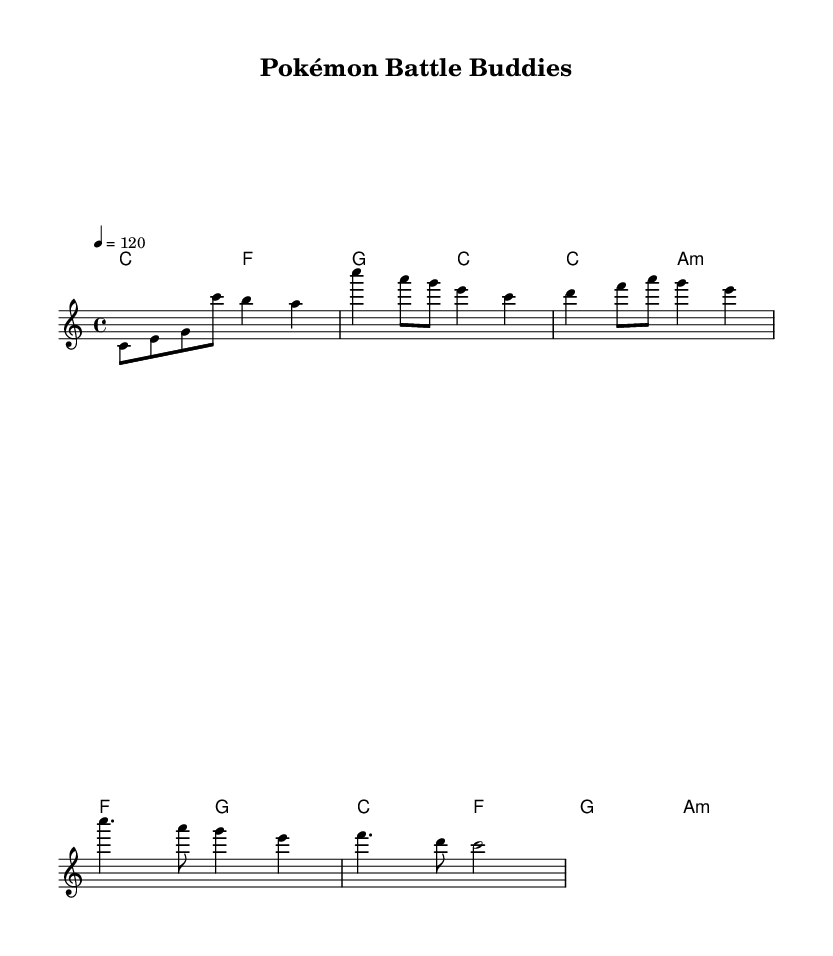What is the key signature of this music? The key signature is indicated by the lack of sharps or flats, which corresponds to C major.
Answer: C major What is the time signature of this piece? The time signature is found at the beginning of the score, which shows four beats per measure (4/4).
Answer: 4/4 What is the tempo marking of the music? The tempo marking appears as "4 = 120," indicating the speed of the piece is set to 120 beats per minute.
Answer: 120 How many measures are in the intro section? By counting the measures in the melody section specifically for the intro, there are two measures present.
Answer: 2 In what section does the lyrics mention "Tra" and "dreams"? These words are part of the verse lyrics, which precede the chorus, as indicated by their placement in the score.
Answer: Verse What type of musical style does this piece represent? The style is denoted by the groove and structure, representing the upbeat feel common in R&B music.
Answer: Rhythm and blues What is the main theme addressed in the lyrics? The lyrics focus on friendship and teamwork, referencing the bonding over Pokémon battles as the central theme.
Answer: Friendship and teamwork 